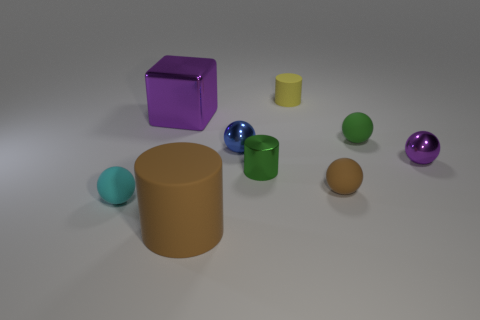Subtract all brown balls. How many balls are left? 4 Subtract all tiny green balls. How many balls are left? 4 Add 1 big yellow metallic objects. How many objects exist? 10 Subtract all yellow balls. Subtract all cyan cylinders. How many balls are left? 5 Subtract all blocks. How many objects are left? 8 Subtract all tiny gray shiny cubes. Subtract all metallic cylinders. How many objects are left? 8 Add 8 small yellow things. How many small yellow things are left? 9 Add 4 tiny red matte spheres. How many tiny red matte spheres exist? 4 Subtract 1 cyan spheres. How many objects are left? 8 